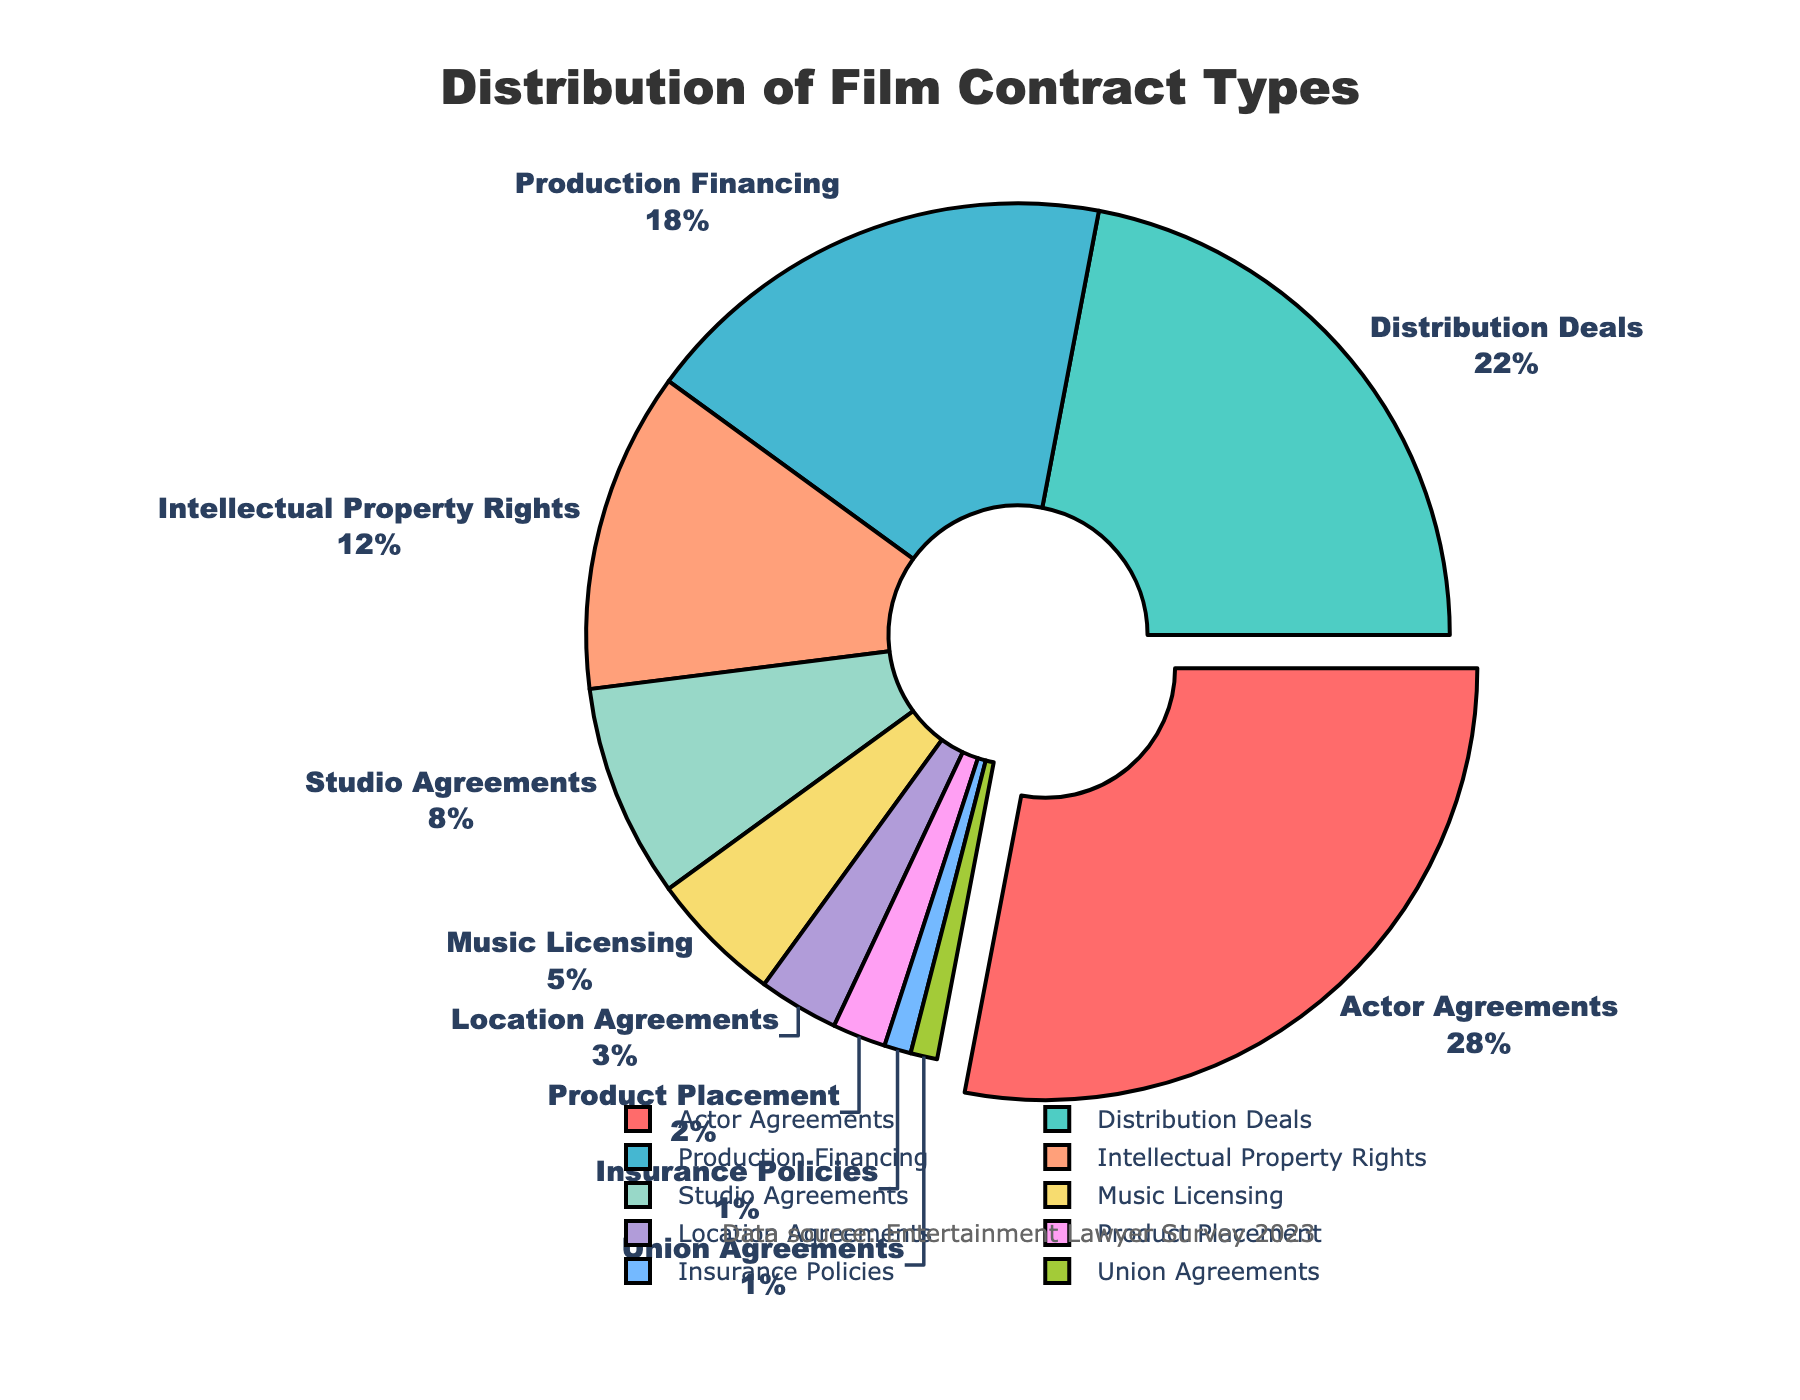What type of contract is handled the most by entertainment lawyers? By looking at the pie chart, the largest segment is for “Actor Agreements” with 28%. This type is emphasized by the pie chart as it’s slightly pulled out for emphasis.
Answer: Actor Agreements How much more is the percentage for Actor Agreements compared to Studio Agreements? Actor Agreements have 28%, while Studio Agreements have 8%. The difference is calculated as 28% - 8% = 20%.
Answer: 20% What is the combined percentage for Music Licensing and Location Agreements? Music Licensing is 5% and Location Agreements are 3%. The combined percentage is 5% + 3% = 8%.
Answer: 8% Which types of contracts collectively make up 30%? The contracts are Production Financing (18%) and Intellectual Property Rights (12%). Their combined total is 18% + 12% = 30%.
Answer: Production Financing and Intellectual Property Rights Is the percentage of Distribution Deals greater than, less than, or equal to the combined percentages of Product Placement and Insurance Policies? Distribution Deals constitute 22%. Product Placement is 2% and Insurance Policies are 1%. Their combined percentage is 2% + 1% = 3%. Hence, 22% is greater than 3%.
Answer: Greater than What are the total percentages of contracts related to intellectual property and licensing combined? Intellectual Property Rights is 12% and Music Licensing is 5%, adding up to a total of 12% + 5% = 17%.
Answer: 17% Which contract type is represented by the smallest segment and what is its percentage? The smallest segment belongs to Union Agreements, with a percentage of 1%.
Answer: Union Agreements, 1% What is the median value of the percentages of the contract types displayed? To find the median, list the percentages in ascending order: [1, 1, 2, 3, 5, 8, 12, 18, 22, 28]. The median is the average of the 5th and 6th values: (5 + 8) / 2 = 6.5%.
Answer: 6.5% If Actor Agreements and Distribution Deals together represent 50% of the contracts, what percentage is contributed by the remaining contract types? Actor Agreements account for 28%, and Distribution Deals for 22%. Their combined percentage is 28% + 22% = 50%. The total percentage is 100%, so the remaining contracts contribute 100% - 50% = 50%.
Answer: 50% What type of visual adjustment is made to highlight the most frequent contract type? The most frequent type, Actor Agreements, is visually highlighted by slightly pulling out its segment from the pie chart.
Answer: Segment pulled out 